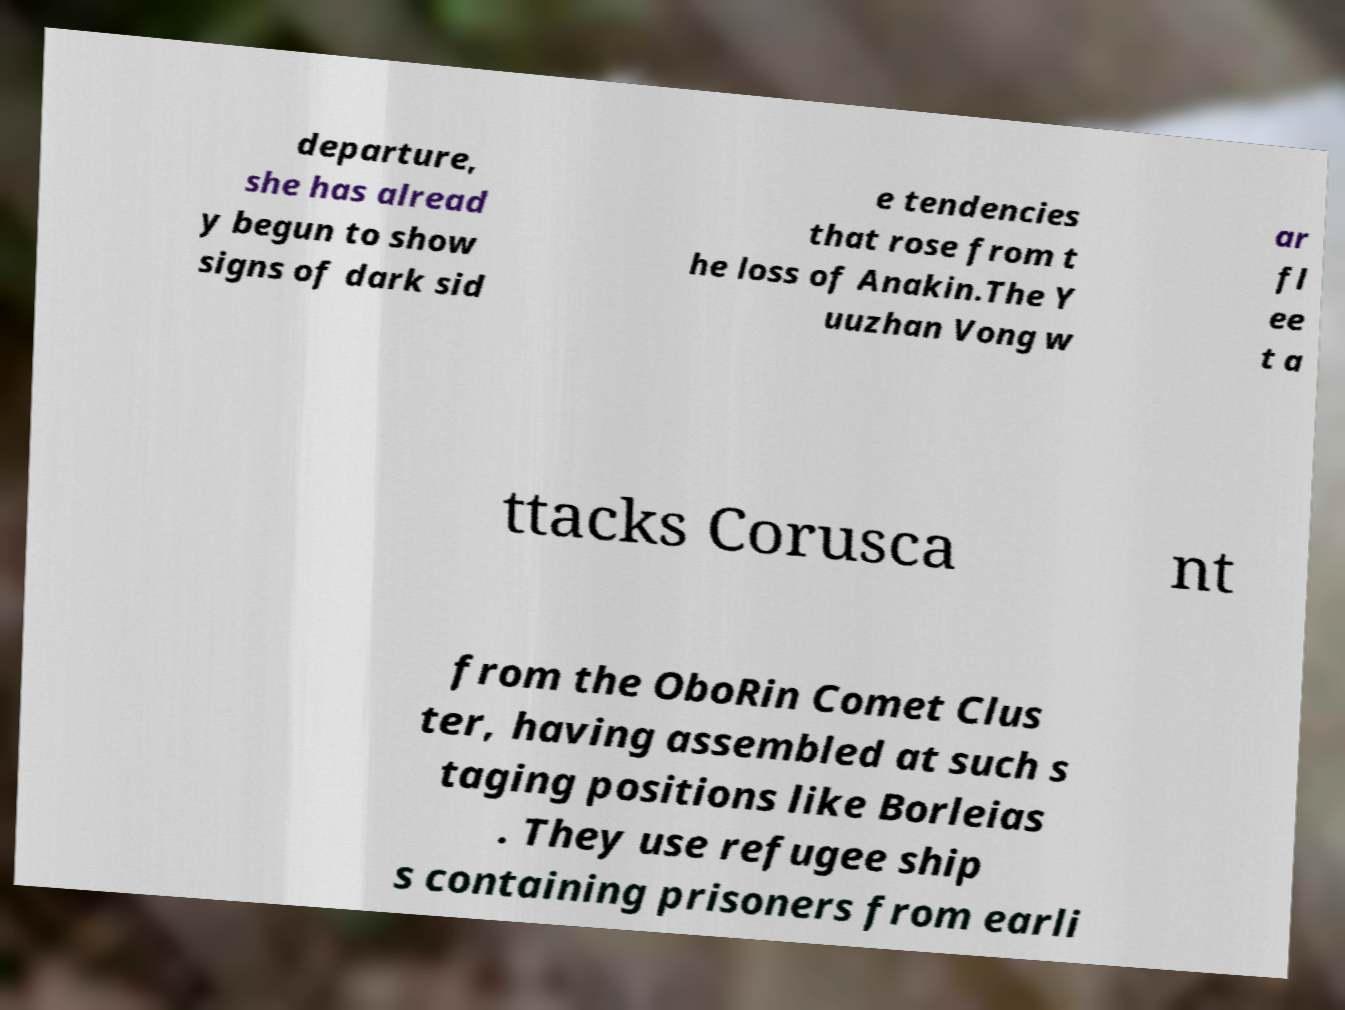For documentation purposes, I need the text within this image transcribed. Could you provide that? departure, she has alread y begun to show signs of dark sid e tendencies that rose from t he loss of Anakin.The Y uuzhan Vong w ar fl ee t a ttacks Corusca nt from the OboRin Comet Clus ter, having assembled at such s taging positions like Borleias . They use refugee ship s containing prisoners from earli 